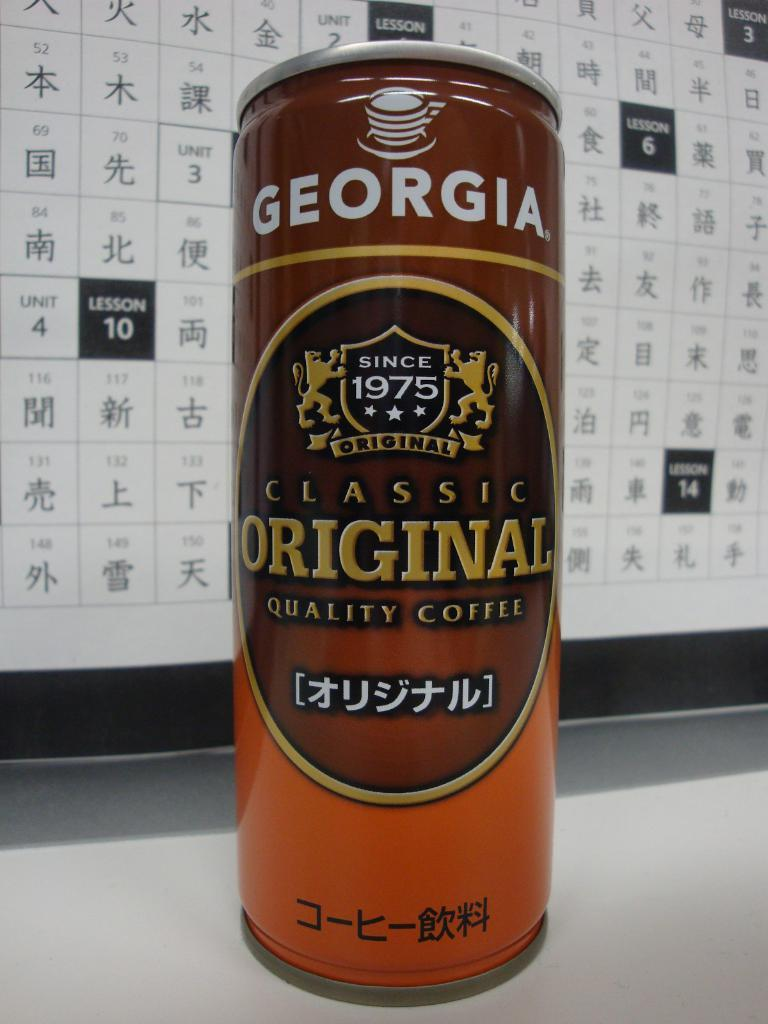<image>
Write a terse but informative summary of the picture. A tall can of Georgia classic original quality coffee. 